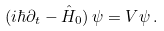Convert formula to latex. <formula><loc_0><loc_0><loc_500><loc_500>( i \hbar { \partial } _ { t } - \hat { H } _ { 0 } ) \, \psi = V \psi \, .</formula> 